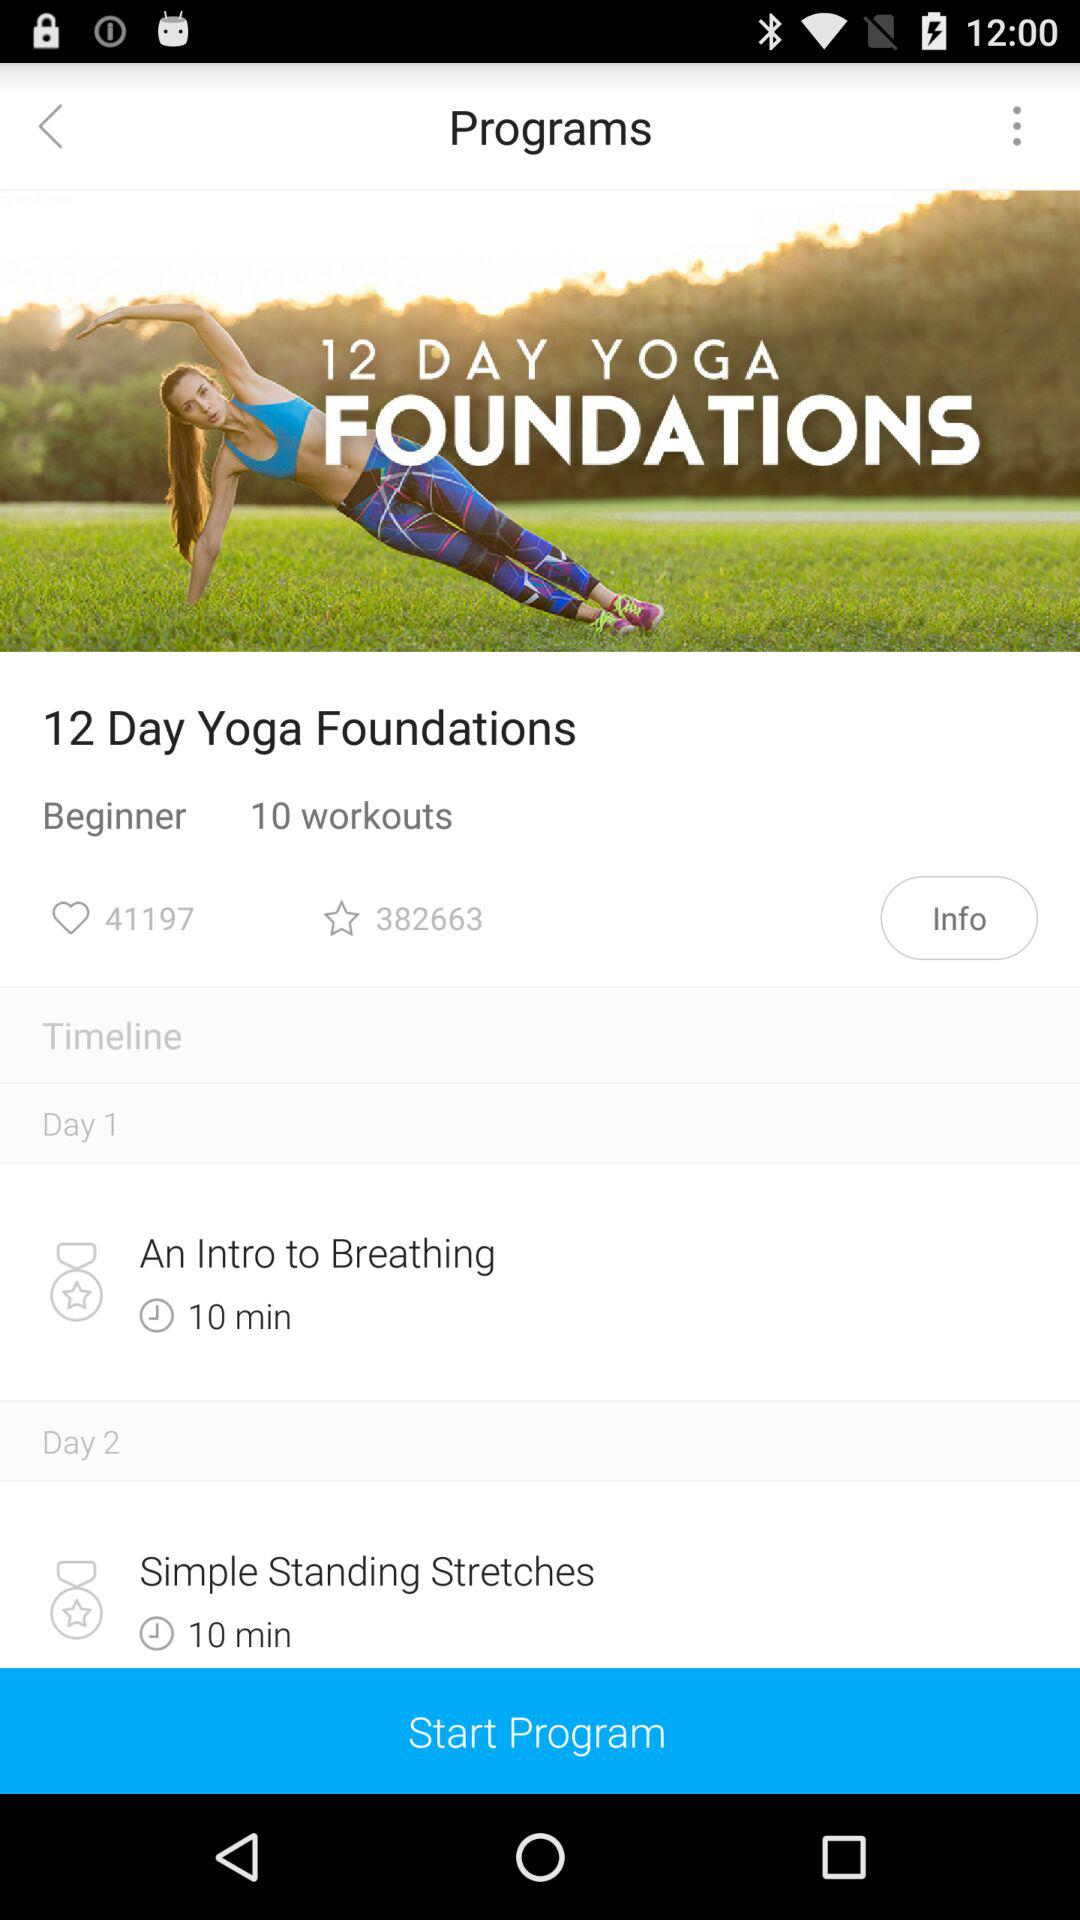How many workouts are there in this program?
Answer the question using a single word or phrase. 10 